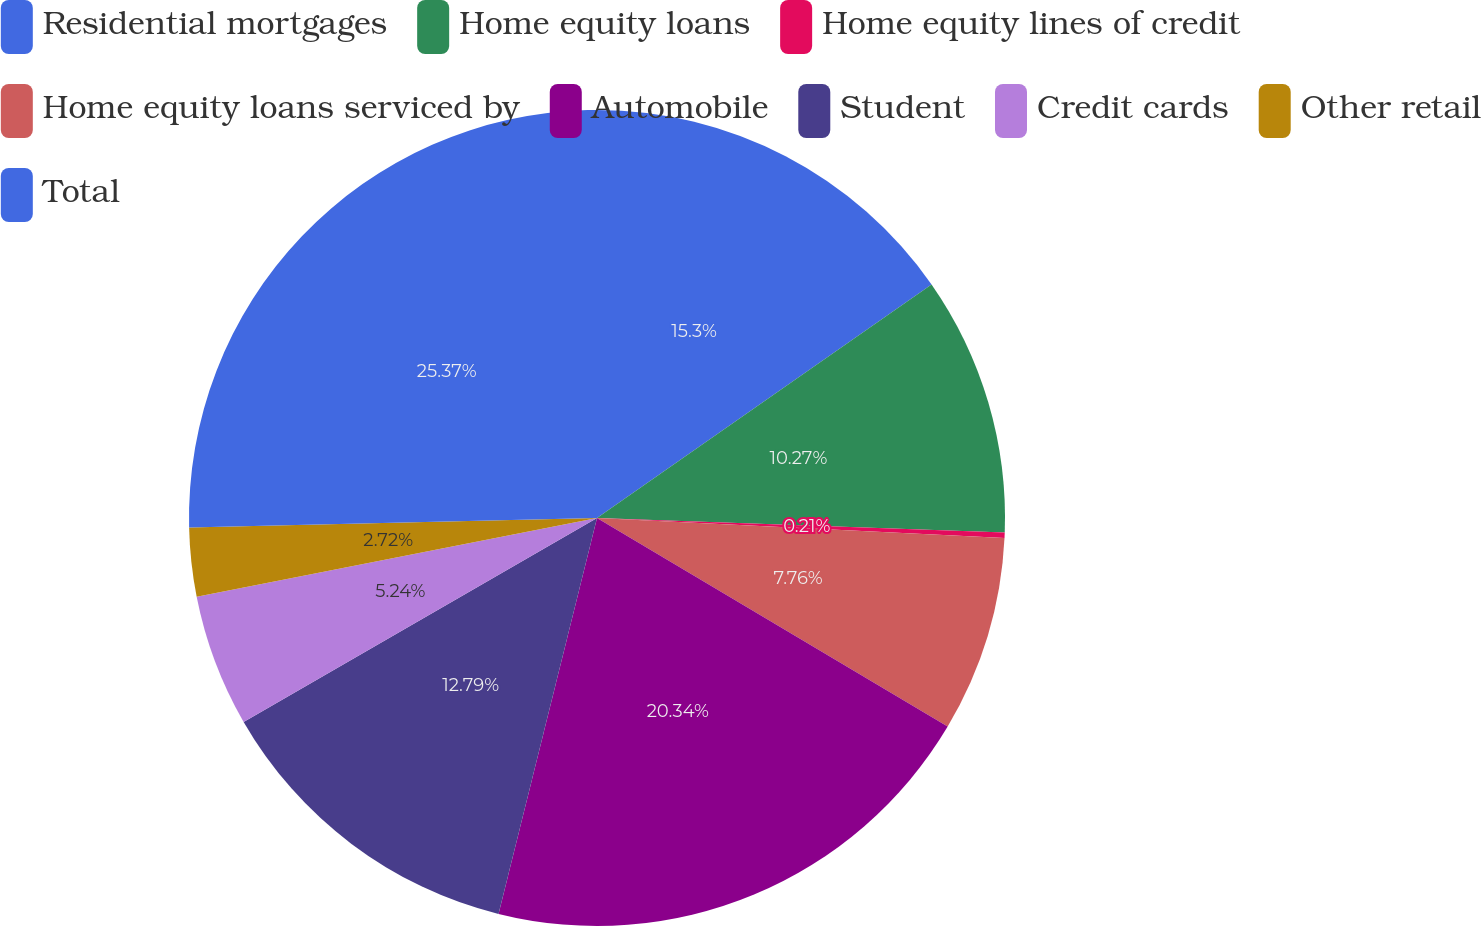Convert chart to OTSL. <chart><loc_0><loc_0><loc_500><loc_500><pie_chart><fcel>Residential mortgages<fcel>Home equity loans<fcel>Home equity lines of credit<fcel>Home equity loans serviced by<fcel>Automobile<fcel>Student<fcel>Credit cards<fcel>Other retail<fcel>Total<nl><fcel>15.3%<fcel>10.27%<fcel>0.21%<fcel>7.76%<fcel>20.34%<fcel>12.79%<fcel>5.24%<fcel>2.72%<fcel>25.37%<nl></chart> 